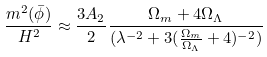<formula> <loc_0><loc_0><loc_500><loc_500>\frac { m ^ { 2 } ( \bar { \phi } ) } { H ^ { 2 } } \approx \frac { 3 A _ { 2 } } { 2 } \frac { \Omega _ { m } + 4 \Omega _ { \Lambda } } { ( \lambda ^ { - 2 } + 3 ( \frac { \Omega _ { m } } { \Omega _ { \Lambda } } + 4 ) ^ { - 2 } ) }</formula> 